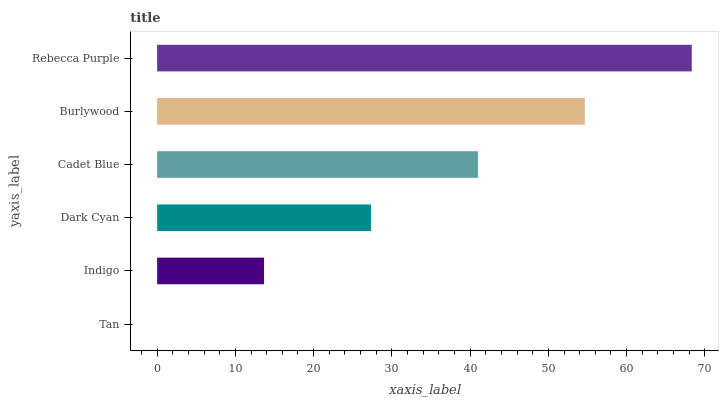Is Tan the minimum?
Answer yes or no. Yes. Is Rebecca Purple the maximum?
Answer yes or no. Yes. Is Indigo the minimum?
Answer yes or no. No. Is Indigo the maximum?
Answer yes or no. No. Is Indigo greater than Tan?
Answer yes or no. Yes. Is Tan less than Indigo?
Answer yes or no. Yes. Is Tan greater than Indigo?
Answer yes or no. No. Is Indigo less than Tan?
Answer yes or no. No. Is Cadet Blue the high median?
Answer yes or no. Yes. Is Dark Cyan the low median?
Answer yes or no. Yes. Is Dark Cyan the high median?
Answer yes or no. No. Is Rebecca Purple the low median?
Answer yes or no. No. 